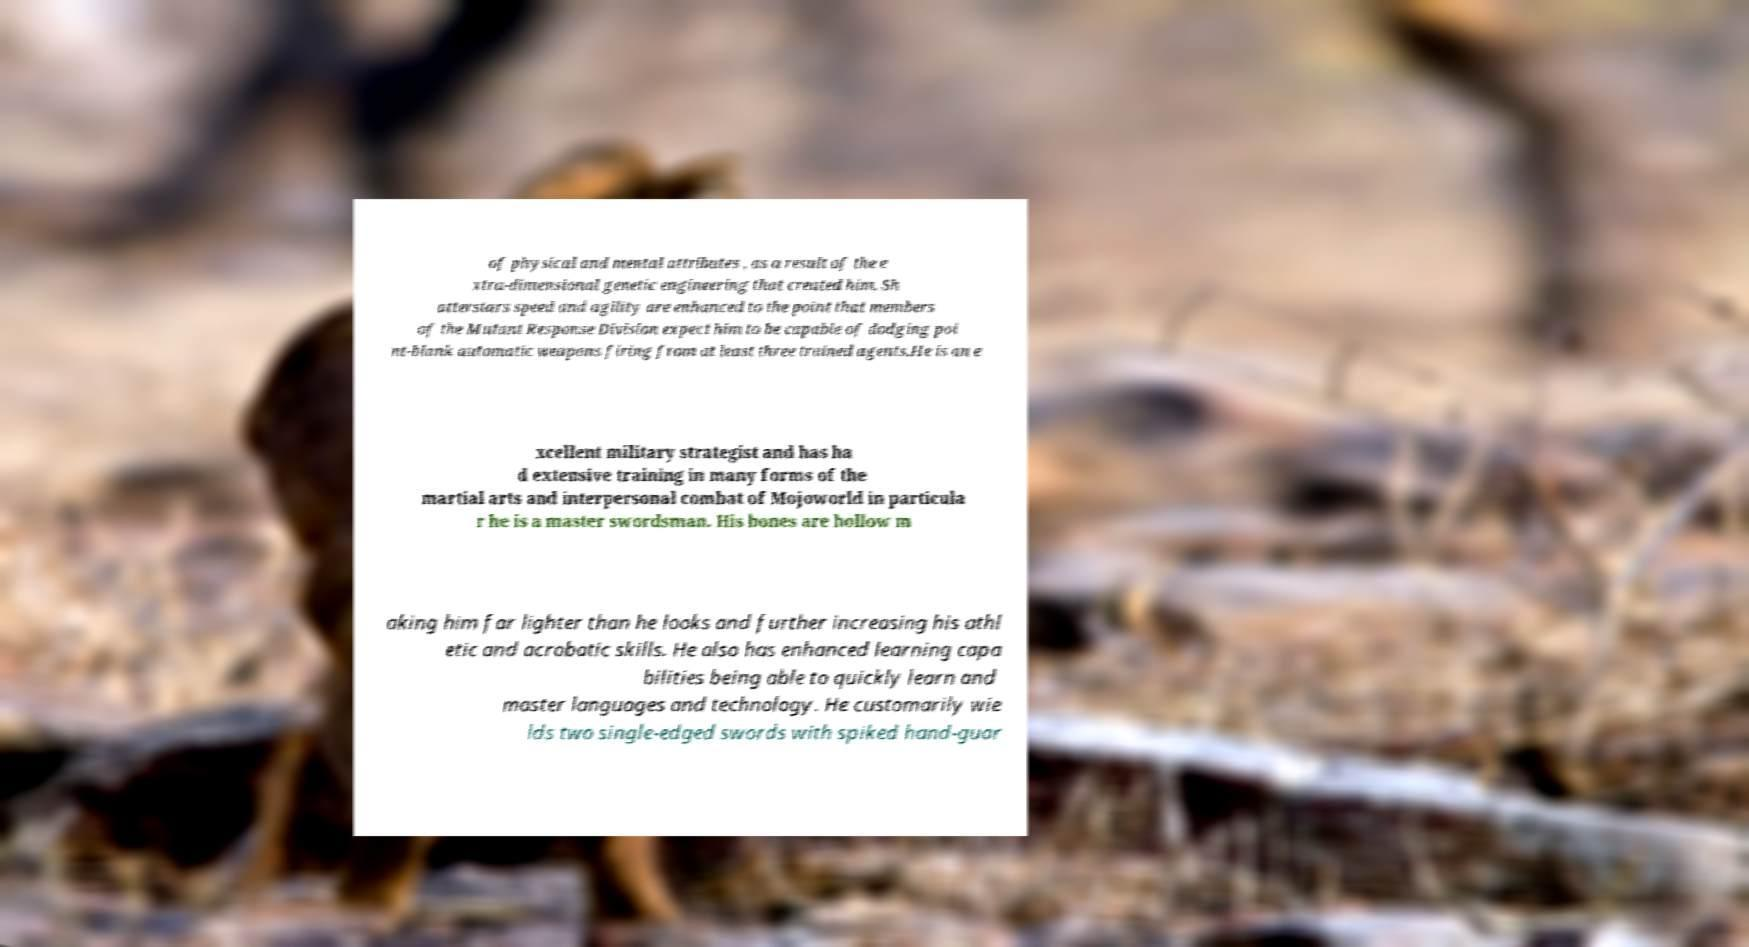For documentation purposes, I need the text within this image transcribed. Could you provide that? of physical and mental attributes , as a result of the e xtra-dimensional genetic engineering that created him. Sh atterstars speed and agility are enhanced to the point that members of the Mutant Response Division expect him to be capable of dodging poi nt-blank automatic weapons firing from at least three trained agents.He is an e xcellent military strategist and has ha d extensive training in many forms of the martial arts and interpersonal combat of Mojoworld in particula r he is a master swordsman. His bones are hollow m aking him far lighter than he looks and further increasing his athl etic and acrobatic skills. He also has enhanced learning capa bilities being able to quickly learn and master languages and technology. He customarily wie lds two single-edged swords with spiked hand-guar 